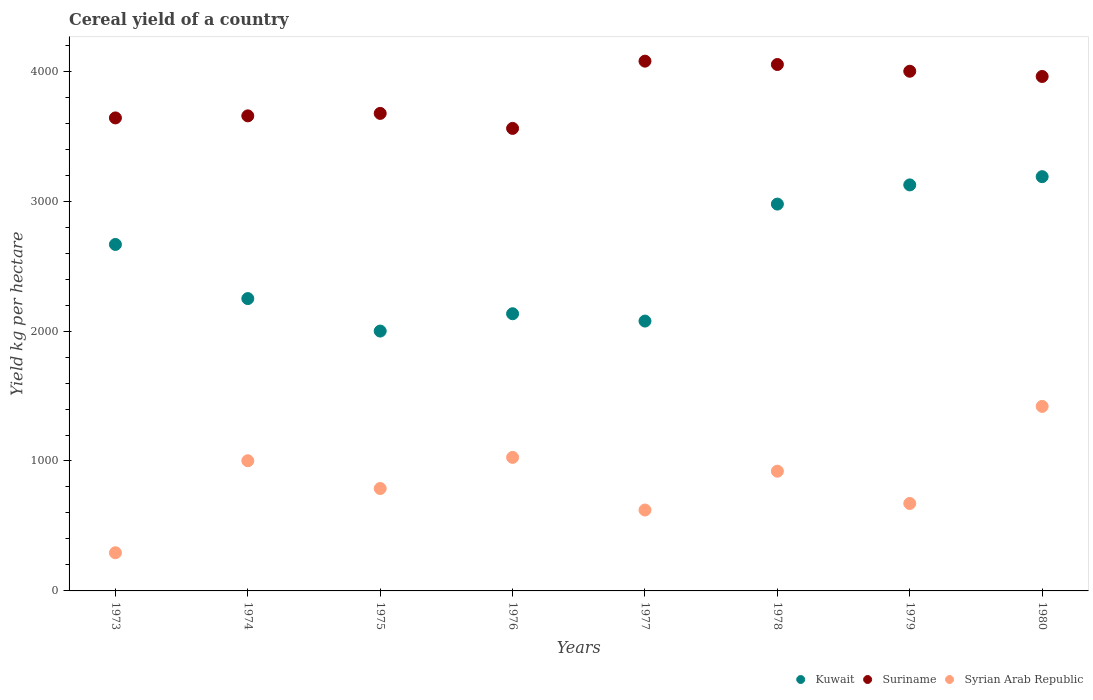How many different coloured dotlines are there?
Your answer should be compact. 3. What is the total cereal yield in Suriname in 1980?
Make the answer very short. 3959.52. Across all years, what is the maximum total cereal yield in Syrian Arab Republic?
Offer a very short reply. 1420.35. Across all years, what is the minimum total cereal yield in Syrian Arab Republic?
Your answer should be very brief. 293.83. In which year was the total cereal yield in Kuwait minimum?
Offer a very short reply. 1975. What is the total total cereal yield in Suriname in the graph?
Your answer should be very brief. 3.06e+04. What is the difference between the total cereal yield in Kuwait in 1978 and that in 1979?
Provide a succinct answer. -147.73. What is the difference between the total cereal yield in Syrian Arab Republic in 1980 and the total cereal yield in Suriname in 1974?
Offer a terse response. -2236.03. What is the average total cereal yield in Suriname per year?
Offer a very short reply. 3827.56. In the year 1978, what is the difference between the total cereal yield in Syrian Arab Republic and total cereal yield in Suriname?
Offer a very short reply. -3130.17. What is the ratio of the total cereal yield in Suriname in 1977 to that in 1980?
Offer a very short reply. 1.03. Is the total cereal yield in Kuwait in 1973 less than that in 1974?
Your response must be concise. No. Is the difference between the total cereal yield in Syrian Arab Republic in 1973 and 1980 greater than the difference between the total cereal yield in Suriname in 1973 and 1980?
Offer a terse response. No. What is the difference between the highest and the second highest total cereal yield in Kuwait?
Offer a terse response. 63.41. What is the difference between the highest and the lowest total cereal yield in Syrian Arab Republic?
Provide a short and direct response. 1126.52. Is the sum of the total cereal yield in Syrian Arab Republic in 1973 and 1980 greater than the maximum total cereal yield in Suriname across all years?
Your answer should be very brief. No. Is it the case that in every year, the sum of the total cereal yield in Suriname and total cereal yield in Kuwait  is greater than the total cereal yield in Syrian Arab Republic?
Make the answer very short. Yes. Does the total cereal yield in Syrian Arab Republic monotonically increase over the years?
Offer a terse response. No. Is the total cereal yield in Kuwait strictly greater than the total cereal yield in Syrian Arab Republic over the years?
Your answer should be compact. Yes. Is the total cereal yield in Kuwait strictly less than the total cereal yield in Suriname over the years?
Provide a succinct answer. Yes. How many years are there in the graph?
Keep it short and to the point. 8. What is the difference between two consecutive major ticks on the Y-axis?
Ensure brevity in your answer.  1000. Does the graph contain any zero values?
Provide a short and direct response. No. Does the graph contain grids?
Ensure brevity in your answer.  No. Where does the legend appear in the graph?
Your response must be concise. Bottom right. How many legend labels are there?
Provide a succinct answer. 3. How are the legend labels stacked?
Offer a terse response. Horizontal. What is the title of the graph?
Your answer should be compact. Cereal yield of a country. What is the label or title of the X-axis?
Offer a terse response. Years. What is the label or title of the Y-axis?
Give a very brief answer. Yield kg per hectare. What is the Yield kg per hectare of Kuwait in 1973?
Your response must be concise. 2666.67. What is the Yield kg per hectare in Suriname in 1973?
Your response must be concise. 3640.58. What is the Yield kg per hectare of Syrian Arab Republic in 1973?
Give a very brief answer. 293.83. What is the Yield kg per hectare of Kuwait in 1974?
Your response must be concise. 2250. What is the Yield kg per hectare in Suriname in 1974?
Your answer should be very brief. 3656.38. What is the Yield kg per hectare in Syrian Arab Republic in 1974?
Offer a very short reply. 1001.9. What is the Yield kg per hectare in Kuwait in 1975?
Provide a succinct answer. 2000. What is the Yield kg per hectare of Suriname in 1975?
Your answer should be compact. 3675.34. What is the Yield kg per hectare in Syrian Arab Republic in 1975?
Provide a short and direct response. 788.24. What is the Yield kg per hectare of Kuwait in 1976?
Keep it short and to the point. 2133.33. What is the Yield kg per hectare in Suriname in 1976?
Offer a very short reply. 3559.86. What is the Yield kg per hectare in Syrian Arab Republic in 1976?
Give a very brief answer. 1027.72. What is the Yield kg per hectare of Kuwait in 1977?
Provide a succinct answer. 2076.92. What is the Yield kg per hectare of Suriname in 1977?
Your answer should be compact. 4077.41. What is the Yield kg per hectare of Syrian Arab Republic in 1977?
Provide a short and direct response. 622.7. What is the Yield kg per hectare of Kuwait in 1978?
Offer a very short reply. 2977.27. What is the Yield kg per hectare in Suriname in 1978?
Your response must be concise. 4051.66. What is the Yield kg per hectare in Syrian Arab Republic in 1978?
Your answer should be very brief. 921.49. What is the Yield kg per hectare of Kuwait in 1979?
Offer a terse response. 3125. What is the Yield kg per hectare of Suriname in 1979?
Offer a terse response. 3999.73. What is the Yield kg per hectare in Syrian Arab Republic in 1979?
Your response must be concise. 673.16. What is the Yield kg per hectare of Kuwait in 1980?
Your answer should be very brief. 3188.41. What is the Yield kg per hectare of Suriname in 1980?
Keep it short and to the point. 3959.52. What is the Yield kg per hectare in Syrian Arab Republic in 1980?
Provide a short and direct response. 1420.35. Across all years, what is the maximum Yield kg per hectare in Kuwait?
Your answer should be very brief. 3188.41. Across all years, what is the maximum Yield kg per hectare of Suriname?
Make the answer very short. 4077.41. Across all years, what is the maximum Yield kg per hectare in Syrian Arab Republic?
Provide a short and direct response. 1420.35. Across all years, what is the minimum Yield kg per hectare of Kuwait?
Your response must be concise. 2000. Across all years, what is the minimum Yield kg per hectare in Suriname?
Ensure brevity in your answer.  3559.86. Across all years, what is the minimum Yield kg per hectare of Syrian Arab Republic?
Provide a short and direct response. 293.83. What is the total Yield kg per hectare in Kuwait in the graph?
Provide a short and direct response. 2.04e+04. What is the total Yield kg per hectare of Suriname in the graph?
Offer a very short reply. 3.06e+04. What is the total Yield kg per hectare in Syrian Arab Republic in the graph?
Provide a short and direct response. 6749.39. What is the difference between the Yield kg per hectare in Kuwait in 1973 and that in 1974?
Provide a short and direct response. 416.67. What is the difference between the Yield kg per hectare in Suriname in 1973 and that in 1974?
Keep it short and to the point. -15.79. What is the difference between the Yield kg per hectare of Syrian Arab Republic in 1973 and that in 1974?
Keep it short and to the point. -708.08. What is the difference between the Yield kg per hectare of Kuwait in 1973 and that in 1975?
Your response must be concise. 666.67. What is the difference between the Yield kg per hectare of Suriname in 1973 and that in 1975?
Your answer should be very brief. -34.75. What is the difference between the Yield kg per hectare of Syrian Arab Republic in 1973 and that in 1975?
Provide a succinct answer. -494.42. What is the difference between the Yield kg per hectare in Kuwait in 1973 and that in 1976?
Give a very brief answer. 533.33. What is the difference between the Yield kg per hectare of Suriname in 1973 and that in 1976?
Give a very brief answer. 80.72. What is the difference between the Yield kg per hectare in Syrian Arab Republic in 1973 and that in 1976?
Your answer should be very brief. -733.89. What is the difference between the Yield kg per hectare in Kuwait in 1973 and that in 1977?
Provide a short and direct response. 589.74. What is the difference between the Yield kg per hectare of Suriname in 1973 and that in 1977?
Make the answer very short. -436.83. What is the difference between the Yield kg per hectare of Syrian Arab Republic in 1973 and that in 1977?
Ensure brevity in your answer.  -328.87. What is the difference between the Yield kg per hectare of Kuwait in 1973 and that in 1978?
Keep it short and to the point. -310.61. What is the difference between the Yield kg per hectare of Suriname in 1973 and that in 1978?
Keep it short and to the point. -411.08. What is the difference between the Yield kg per hectare in Syrian Arab Republic in 1973 and that in 1978?
Make the answer very short. -627.66. What is the difference between the Yield kg per hectare of Kuwait in 1973 and that in 1979?
Your response must be concise. -458.33. What is the difference between the Yield kg per hectare of Suriname in 1973 and that in 1979?
Offer a very short reply. -359.15. What is the difference between the Yield kg per hectare of Syrian Arab Republic in 1973 and that in 1979?
Provide a succinct answer. -379.33. What is the difference between the Yield kg per hectare in Kuwait in 1973 and that in 1980?
Offer a terse response. -521.74. What is the difference between the Yield kg per hectare of Suriname in 1973 and that in 1980?
Your answer should be compact. -318.94. What is the difference between the Yield kg per hectare of Syrian Arab Republic in 1973 and that in 1980?
Keep it short and to the point. -1126.52. What is the difference between the Yield kg per hectare of Kuwait in 1974 and that in 1975?
Keep it short and to the point. 250. What is the difference between the Yield kg per hectare of Suriname in 1974 and that in 1975?
Keep it short and to the point. -18.96. What is the difference between the Yield kg per hectare of Syrian Arab Republic in 1974 and that in 1975?
Offer a terse response. 213.66. What is the difference between the Yield kg per hectare of Kuwait in 1974 and that in 1976?
Give a very brief answer. 116.67. What is the difference between the Yield kg per hectare in Suriname in 1974 and that in 1976?
Give a very brief answer. 96.51. What is the difference between the Yield kg per hectare in Syrian Arab Republic in 1974 and that in 1976?
Give a very brief answer. -25.82. What is the difference between the Yield kg per hectare of Kuwait in 1974 and that in 1977?
Ensure brevity in your answer.  173.08. What is the difference between the Yield kg per hectare in Suriname in 1974 and that in 1977?
Provide a short and direct response. -421.04. What is the difference between the Yield kg per hectare of Syrian Arab Republic in 1974 and that in 1977?
Offer a very short reply. 379.2. What is the difference between the Yield kg per hectare of Kuwait in 1974 and that in 1978?
Your answer should be very brief. -727.27. What is the difference between the Yield kg per hectare in Suriname in 1974 and that in 1978?
Provide a short and direct response. -395.29. What is the difference between the Yield kg per hectare of Syrian Arab Republic in 1974 and that in 1978?
Offer a terse response. 80.42. What is the difference between the Yield kg per hectare in Kuwait in 1974 and that in 1979?
Your answer should be very brief. -875. What is the difference between the Yield kg per hectare of Suriname in 1974 and that in 1979?
Your answer should be very brief. -343.35. What is the difference between the Yield kg per hectare of Syrian Arab Republic in 1974 and that in 1979?
Keep it short and to the point. 328.75. What is the difference between the Yield kg per hectare in Kuwait in 1974 and that in 1980?
Offer a very short reply. -938.41. What is the difference between the Yield kg per hectare in Suriname in 1974 and that in 1980?
Your answer should be compact. -303.14. What is the difference between the Yield kg per hectare in Syrian Arab Republic in 1974 and that in 1980?
Offer a terse response. -418.45. What is the difference between the Yield kg per hectare in Kuwait in 1975 and that in 1976?
Keep it short and to the point. -133.33. What is the difference between the Yield kg per hectare in Suriname in 1975 and that in 1976?
Your answer should be very brief. 115.47. What is the difference between the Yield kg per hectare in Syrian Arab Republic in 1975 and that in 1976?
Keep it short and to the point. -239.48. What is the difference between the Yield kg per hectare of Kuwait in 1975 and that in 1977?
Give a very brief answer. -76.92. What is the difference between the Yield kg per hectare of Suriname in 1975 and that in 1977?
Your answer should be very brief. -402.08. What is the difference between the Yield kg per hectare of Syrian Arab Republic in 1975 and that in 1977?
Your answer should be very brief. 165.54. What is the difference between the Yield kg per hectare in Kuwait in 1975 and that in 1978?
Ensure brevity in your answer.  -977.27. What is the difference between the Yield kg per hectare of Suriname in 1975 and that in 1978?
Give a very brief answer. -376.33. What is the difference between the Yield kg per hectare in Syrian Arab Republic in 1975 and that in 1978?
Offer a very short reply. -133.25. What is the difference between the Yield kg per hectare of Kuwait in 1975 and that in 1979?
Give a very brief answer. -1125. What is the difference between the Yield kg per hectare in Suriname in 1975 and that in 1979?
Keep it short and to the point. -324.39. What is the difference between the Yield kg per hectare of Syrian Arab Republic in 1975 and that in 1979?
Keep it short and to the point. 115.09. What is the difference between the Yield kg per hectare of Kuwait in 1975 and that in 1980?
Offer a terse response. -1188.41. What is the difference between the Yield kg per hectare of Suriname in 1975 and that in 1980?
Keep it short and to the point. -284.18. What is the difference between the Yield kg per hectare of Syrian Arab Republic in 1975 and that in 1980?
Offer a terse response. -632.11. What is the difference between the Yield kg per hectare of Kuwait in 1976 and that in 1977?
Your answer should be compact. 56.41. What is the difference between the Yield kg per hectare in Suriname in 1976 and that in 1977?
Your answer should be compact. -517.55. What is the difference between the Yield kg per hectare of Syrian Arab Republic in 1976 and that in 1977?
Offer a very short reply. 405.02. What is the difference between the Yield kg per hectare in Kuwait in 1976 and that in 1978?
Offer a very short reply. -843.94. What is the difference between the Yield kg per hectare of Suriname in 1976 and that in 1978?
Your response must be concise. -491.8. What is the difference between the Yield kg per hectare in Syrian Arab Republic in 1976 and that in 1978?
Offer a very short reply. 106.23. What is the difference between the Yield kg per hectare in Kuwait in 1976 and that in 1979?
Make the answer very short. -991.67. What is the difference between the Yield kg per hectare of Suriname in 1976 and that in 1979?
Your answer should be very brief. -439.87. What is the difference between the Yield kg per hectare of Syrian Arab Republic in 1976 and that in 1979?
Offer a very short reply. 354.56. What is the difference between the Yield kg per hectare of Kuwait in 1976 and that in 1980?
Give a very brief answer. -1055.07. What is the difference between the Yield kg per hectare in Suriname in 1976 and that in 1980?
Your response must be concise. -399.65. What is the difference between the Yield kg per hectare in Syrian Arab Republic in 1976 and that in 1980?
Provide a short and direct response. -392.63. What is the difference between the Yield kg per hectare in Kuwait in 1977 and that in 1978?
Offer a terse response. -900.35. What is the difference between the Yield kg per hectare in Suriname in 1977 and that in 1978?
Provide a short and direct response. 25.75. What is the difference between the Yield kg per hectare in Syrian Arab Republic in 1977 and that in 1978?
Your answer should be compact. -298.79. What is the difference between the Yield kg per hectare of Kuwait in 1977 and that in 1979?
Your answer should be very brief. -1048.08. What is the difference between the Yield kg per hectare in Suriname in 1977 and that in 1979?
Offer a very short reply. 77.69. What is the difference between the Yield kg per hectare in Syrian Arab Republic in 1977 and that in 1979?
Provide a succinct answer. -50.46. What is the difference between the Yield kg per hectare of Kuwait in 1977 and that in 1980?
Your response must be concise. -1111.48. What is the difference between the Yield kg per hectare in Suriname in 1977 and that in 1980?
Make the answer very short. 117.9. What is the difference between the Yield kg per hectare of Syrian Arab Republic in 1977 and that in 1980?
Provide a short and direct response. -797.65. What is the difference between the Yield kg per hectare of Kuwait in 1978 and that in 1979?
Ensure brevity in your answer.  -147.73. What is the difference between the Yield kg per hectare of Suriname in 1978 and that in 1979?
Provide a short and direct response. 51.93. What is the difference between the Yield kg per hectare of Syrian Arab Republic in 1978 and that in 1979?
Provide a short and direct response. 248.33. What is the difference between the Yield kg per hectare of Kuwait in 1978 and that in 1980?
Your response must be concise. -211.13. What is the difference between the Yield kg per hectare in Suriname in 1978 and that in 1980?
Give a very brief answer. 92.14. What is the difference between the Yield kg per hectare of Syrian Arab Republic in 1978 and that in 1980?
Your answer should be compact. -498.86. What is the difference between the Yield kg per hectare in Kuwait in 1979 and that in 1980?
Your answer should be very brief. -63.41. What is the difference between the Yield kg per hectare in Suriname in 1979 and that in 1980?
Provide a short and direct response. 40.21. What is the difference between the Yield kg per hectare in Syrian Arab Republic in 1979 and that in 1980?
Your response must be concise. -747.19. What is the difference between the Yield kg per hectare of Kuwait in 1973 and the Yield kg per hectare of Suriname in 1974?
Your answer should be very brief. -989.71. What is the difference between the Yield kg per hectare in Kuwait in 1973 and the Yield kg per hectare in Syrian Arab Republic in 1974?
Make the answer very short. 1664.76. What is the difference between the Yield kg per hectare of Suriname in 1973 and the Yield kg per hectare of Syrian Arab Republic in 1974?
Give a very brief answer. 2638.68. What is the difference between the Yield kg per hectare of Kuwait in 1973 and the Yield kg per hectare of Suriname in 1975?
Give a very brief answer. -1008.67. What is the difference between the Yield kg per hectare in Kuwait in 1973 and the Yield kg per hectare in Syrian Arab Republic in 1975?
Offer a terse response. 1878.42. What is the difference between the Yield kg per hectare of Suriname in 1973 and the Yield kg per hectare of Syrian Arab Republic in 1975?
Offer a very short reply. 2852.34. What is the difference between the Yield kg per hectare in Kuwait in 1973 and the Yield kg per hectare in Suriname in 1976?
Your response must be concise. -893.2. What is the difference between the Yield kg per hectare of Kuwait in 1973 and the Yield kg per hectare of Syrian Arab Republic in 1976?
Offer a terse response. 1638.95. What is the difference between the Yield kg per hectare of Suriname in 1973 and the Yield kg per hectare of Syrian Arab Republic in 1976?
Give a very brief answer. 2612.86. What is the difference between the Yield kg per hectare of Kuwait in 1973 and the Yield kg per hectare of Suriname in 1977?
Provide a succinct answer. -1410.75. What is the difference between the Yield kg per hectare in Kuwait in 1973 and the Yield kg per hectare in Syrian Arab Republic in 1977?
Your response must be concise. 2043.97. What is the difference between the Yield kg per hectare of Suriname in 1973 and the Yield kg per hectare of Syrian Arab Republic in 1977?
Your response must be concise. 3017.88. What is the difference between the Yield kg per hectare in Kuwait in 1973 and the Yield kg per hectare in Suriname in 1978?
Offer a terse response. -1384.99. What is the difference between the Yield kg per hectare in Kuwait in 1973 and the Yield kg per hectare in Syrian Arab Republic in 1978?
Offer a very short reply. 1745.18. What is the difference between the Yield kg per hectare in Suriname in 1973 and the Yield kg per hectare in Syrian Arab Republic in 1978?
Ensure brevity in your answer.  2719.09. What is the difference between the Yield kg per hectare of Kuwait in 1973 and the Yield kg per hectare of Suriname in 1979?
Your response must be concise. -1333.06. What is the difference between the Yield kg per hectare of Kuwait in 1973 and the Yield kg per hectare of Syrian Arab Republic in 1979?
Your answer should be very brief. 1993.51. What is the difference between the Yield kg per hectare in Suriname in 1973 and the Yield kg per hectare in Syrian Arab Republic in 1979?
Keep it short and to the point. 2967.42. What is the difference between the Yield kg per hectare of Kuwait in 1973 and the Yield kg per hectare of Suriname in 1980?
Give a very brief answer. -1292.85. What is the difference between the Yield kg per hectare in Kuwait in 1973 and the Yield kg per hectare in Syrian Arab Republic in 1980?
Offer a very short reply. 1246.32. What is the difference between the Yield kg per hectare in Suriname in 1973 and the Yield kg per hectare in Syrian Arab Republic in 1980?
Keep it short and to the point. 2220.23. What is the difference between the Yield kg per hectare in Kuwait in 1974 and the Yield kg per hectare in Suriname in 1975?
Your response must be concise. -1425.34. What is the difference between the Yield kg per hectare in Kuwait in 1974 and the Yield kg per hectare in Syrian Arab Republic in 1975?
Provide a succinct answer. 1461.76. What is the difference between the Yield kg per hectare of Suriname in 1974 and the Yield kg per hectare of Syrian Arab Republic in 1975?
Make the answer very short. 2868.13. What is the difference between the Yield kg per hectare in Kuwait in 1974 and the Yield kg per hectare in Suriname in 1976?
Make the answer very short. -1309.86. What is the difference between the Yield kg per hectare in Kuwait in 1974 and the Yield kg per hectare in Syrian Arab Republic in 1976?
Provide a short and direct response. 1222.28. What is the difference between the Yield kg per hectare of Suriname in 1974 and the Yield kg per hectare of Syrian Arab Republic in 1976?
Your answer should be compact. 2628.66. What is the difference between the Yield kg per hectare of Kuwait in 1974 and the Yield kg per hectare of Suriname in 1977?
Make the answer very short. -1827.41. What is the difference between the Yield kg per hectare in Kuwait in 1974 and the Yield kg per hectare in Syrian Arab Republic in 1977?
Ensure brevity in your answer.  1627.3. What is the difference between the Yield kg per hectare in Suriname in 1974 and the Yield kg per hectare in Syrian Arab Republic in 1977?
Offer a terse response. 3033.68. What is the difference between the Yield kg per hectare of Kuwait in 1974 and the Yield kg per hectare of Suriname in 1978?
Keep it short and to the point. -1801.66. What is the difference between the Yield kg per hectare in Kuwait in 1974 and the Yield kg per hectare in Syrian Arab Republic in 1978?
Give a very brief answer. 1328.51. What is the difference between the Yield kg per hectare of Suriname in 1974 and the Yield kg per hectare of Syrian Arab Republic in 1978?
Offer a terse response. 2734.89. What is the difference between the Yield kg per hectare of Kuwait in 1974 and the Yield kg per hectare of Suriname in 1979?
Give a very brief answer. -1749.73. What is the difference between the Yield kg per hectare of Kuwait in 1974 and the Yield kg per hectare of Syrian Arab Republic in 1979?
Your answer should be very brief. 1576.84. What is the difference between the Yield kg per hectare in Suriname in 1974 and the Yield kg per hectare in Syrian Arab Republic in 1979?
Your answer should be very brief. 2983.22. What is the difference between the Yield kg per hectare of Kuwait in 1974 and the Yield kg per hectare of Suriname in 1980?
Ensure brevity in your answer.  -1709.52. What is the difference between the Yield kg per hectare in Kuwait in 1974 and the Yield kg per hectare in Syrian Arab Republic in 1980?
Provide a short and direct response. 829.65. What is the difference between the Yield kg per hectare of Suriname in 1974 and the Yield kg per hectare of Syrian Arab Republic in 1980?
Provide a short and direct response. 2236.03. What is the difference between the Yield kg per hectare of Kuwait in 1975 and the Yield kg per hectare of Suriname in 1976?
Offer a very short reply. -1559.86. What is the difference between the Yield kg per hectare in Kuwait in 1975 and the Yield kg per hectare in Syrian Arab Republic in 1976?
Ensure brevity in your answer.  972.28. What is the difference between the Yield kg per hectare in Suriname in 1975 and the Yield kg per hectare in Syrian Arab Republic in 1976?
Provide a succinct answer. 2647.61. What is the difference between the Yield kg per hectare in Kuwait in 1975 and the Yield kg per hectare in Suriname in 1977?
Your answer should be compact. -2077.41. What is the difference between the Yield kg per hectare in Kuwait in 1975 and the Yield kg per hectare in Syrian Arab Republic in 1977?
Provide a short and direct response. 1377.3. What is the difference between the Yield kg per hectare in Suriname in 1975 and the Yield kg per hectare in Syrian Arab Republic in 1977?
Offer a very short reply. 3052.63. What is the difference between the Yield kg per hectare in Kuwait in 1975 and the Yield kg per hectare in Suriname in 1978?
Your answer should be very brief. -2051.66. What is the difference between the Yield kg per hectare in Kuwait in 1975 and the Yield kg per hectare in Syrian Arab Republic in 1978?
Make the answer very short. 1078.51. What is the difference between the Yield kg per hectare of Suriname in 1975 and the Yield kg per hectare of Syrian Arab Republic in 1978?
Make the answer very short. 2753.85. What is the difference between the Yield kg per hectare in Kuwait in 1975 and the Yield kg per hectare in Suriname in 1979?
Your response must be concise. -1999.73. What is the difference between the Yield kg per hectare in Kuwait in 1975 and the Yield kg per hectare in Syrian Arab Republic in 1979?
Your answer should be very brief. 1326.84. What is the difference between the Yield kg per hectare of Suriname in 1975 and the Yield kg per hectare of Syrian Arab Republic in 1979?
Make the answer very short. 3002.18. What is the difference between the Yield kg per hectare in Kuwait in 1975 and the Yield kg per hectare in Suriname in 1980?
Your answer should be compact. -1959.52. What is the difference between the Yield kg per hectare of Kuwait in 1975 and the Yield kg per hectare of Syrian Arab Republic in 1980?
Provide a short and direct response. 579.65. What is the difference between the Yield kg per hectare of Suriname in 1975 and the Yield kg per hectare of Syrian Arab Republic in 1980?
Provide a succinct answer. 2254.98. What is the difference between the Yield kg per hectare of Kuwait in 1976 and the Yield kg per hectare of Suriname in 1977?
Provide a short and direct response. -1944.08. What is the difference between the Yield kg per hectare of Kuwait in 1976 and the Yield kg per hectare of Syrian Arab Republic in 1977?
Keep it short and to the point. 1510.63. What is the difference between the Yield kg per hectare in Suriname in 1976 and the Yield kg per hectare in Syrian Arab Republic in 1977?
Your response must be concise. 2937.16. What is the difference between the Yield kg per hectare in Kuwait in 1976 and the Yield kg per hectare in Suriname in 1978?
Provide a succinct answer. -1918.33. What is the difference between the Yield kg per hectare of Kuwait in 1976 and the Yield kg per hectare of Syrian Arab Republic in 1978?
Provide a short and direct response. 1211.84. What is the difference between the Yield kg per hectare in Suriname in 1976 and the Yield kg per hectare in Syrian Arab Republic in 1978?
Provide a short and direct response. 2638.37. What is the difference between the Yield kg per hectare of Kuwait in 1976 and the Yield kg per hectare of Suriname in 1979?
Offer a very short reply. -1866.4. What is the difference between the Yield kg per hectare of Kuwait in 1976 and the Yield kg per hectare of Syrian Arab Republic in 1979?
Ensure brevity in your answer.  1460.18. What is the difference between the Yield kg per hectare in Suriname in 1976 and the Yield kg per hectare in Syrian Arab Republic in 1979?
Your answer should be very brief. 2886.71. What is the difference between the Yield kg per hectare of Kuwait in 1976 and the Yield kg per hectare of Suriname in 1980?
Give a very brief answer. -1826.18. What is the difference between the Yield kg per hectare in Kuwait in 1976 and the Yield kg per hectare in Syrian Arab Republic in 1980?
Ensure brevity in your answer.  712.98. What is the difference between the Yield kg per hectare of Suriname in 1976 and the Yield kg per hectare of Syrian Arab Republic in 1980?
Your response must be concise. 2139.51. What is the difference between the Yield kg per hectare in Kuwait in 1977 and the Yield kg per hectare in Suriname in 1978?
Keep it short and to the point. -1974.74. What is the difference between the Yield kg per hectare of Kuwait in 1977 and the Yield kg per hectare of Syrian Arab Republic in 1978?
Your response must be concise. 1155.43. What is the difference between the Yield kg per hectare in Suriname in 1977 and the Yield kg per hectare in Syrian Arab Republic in 1978?
Provide a short and direct response. 3155.93. What is the difference between the Yield kg per hectare of Kuwait in 1977 and the Yield kg per hectare of Suriname in 1979?
Your response must be concise. -1922.81. What is the difference between the Yield kg per hectare in Kuwait in 1977 and the Yield kg per hectare in Syrian Arab Republic in 1979?
Give a very brief answer. 1403.77. What is the difference between the Yield kg per hectare of Suriname in 1977 and the Yield kg per hectare of Syrian Arab Republic in 1979?
Your answer should be compact. 3404.26. What is the difference between the Yield kg per hectare of Kuwait in 1977 and the Yield kg per hectare of Suriname in 1980?
Your answer should be very brief. -1882.59. What is the difference between the Yield kg per hectare of Kuwait in 1977 and the Yield kg per hectare of Syrian Arab Republic in 1980?
Provide a short and direct response. 656.57. What is the difference between the Yield kg per hectare in Suriname in 1977 and the Yield kg per hectare in Syrian Arab Republic in 1980?
Your answer should be very brief. 2657.06. What is the difference between the Yield kg per hectare in Kuwait in 1978 and the Yield kg per hectare in Suriname in 1979?
Provide a short and direct response. -1022.46. What is the difference between the Yield kg per hectare of Kuwait in 1978 and the Yield kg per hectare of Syrian Arab Republic in 1979?
Provide a short and direct response. 2304.12. What is the difference between the Yield kg per hectare in Suriname in 1978 and the Yield kg per hectare in Syrian Arab Republic in 1979?
Provide a short and direct response. 3378.51. What is the difference between the Yield kg per hectare in Kuwait in 1978 and the Yield kg per hectare in Suriname in 1980?
Your answer should be compact. -982.24. What is the difference between the Yield kg per hectare of Kuwait in 1978 and the Yield kg per hectare of Syrian Arab Republic in 1980?
Provide a short and direct response. 1556.92. What is the difference between the Yield kg per hectare of Suriname in 1978 and the Yield kg per hectare of Syrian Arab Republic in 1980?
Make the answer very short. 2631.31. What is the difference between the Yield kg per hectare in Kuwait in 1979 and the Yield kg per hectare in Suriname in 1980?
Make the answer very short. -834.52. What is the difference between the Yield kg per hectare in Kuwait in 1979 and the Yield kg per hectare in Syrian Arab Republic in 1980?
Offer a very short reply. 1704.65. What is the difference between the Yield kg per hectare of Suriname in 1979 and the Yield kg per hectare of Syrian Arab Republic in 1980?
Make the answer very short. 2579.38. What is the average Yield kg per hectare in Kuwait per year?
Your answer should be very brief. 2552.2. What is the average Yield kg per hectare of Suriname per year?
Give a very brief answer. 3827.56. What is the average Yield kg per hectare in Syrian Arab Republic per year?
Make the answer very short. 843.67. In the year 1973, what is the difference between the Yield kg per hectare of Kuwait and Yield kg per hectare of Suriname?
Provide a short and direct response. -973.91. In the year 1973, what is the difference between the Yield kg per hectare in Kuwait and Yield kg per hectare in Syrian Arab Republic?
Keep it short and to the point. 2372.84. In the year 1973, what is the difference between the Yield kg per hectare of Suriname and Yield kg per hectare of Syrian Arab Republic?
Keep it short and to the point. 3346.75. In the year 1974, what is the difference between the Yield kg per hectare of Kuwait and Yield kg per hectare of Suriname?
Your answer should be very brief. -1406.38. In the year 1974, what is the difference between the Yield kg per hectare in Kuwait and Yield kg per hectare in Syrian Arab Republic?
Provide a short and direct response. 1248.1. In the year 1974, what is the difference between the Yield kg per hectare of Suriname and Yield kg per hectare of Syrian Arab Republic?
Your answer should be compact. 2654.47. In the year 1975, what is the difference between the Yield kg per hectare of Kuwait and Yield kg per hectare of Suriname?
Your answer should be compact. -1675.34. In the year 1975, what is the difference between the Yield kg per hectare in Kuwait and Yield kg per hectare in Syrian Arab Republic?
Keep it short and to the point. 1211.76. In the year 1975, what is the difference between the Yield kg per hectare in Suriname and Yield kg per hectare in Syrian Arab Republic?
Offer a very short reply. 2887.09. In the year 1976, what is the difference between the Yield kg per hectare of Kuwait and Yield kg per hectare of Suriname?
Make the answer very short. -1426.53. In the year 1976, what is the difference between the Yield kg per hectare of Kuwait and Yield kg per hectare of Syrian Arab Republic?
Offer a terse response. 1105.61. In the year 1976, what is the difference between the Yield kg per hectare in Suriname and Yield kg per hectare in Syrian Arab Republic?
Keep it short and to the point. 2532.14. In the year 1977, what is the difference between the Yield kg per hectare of Kuwait and Yield kg per hectare of Suriname?
Keep it short and to the point. -2000.49. In the year 1977, what is the difference between the Yield kg per hectare in Kuwait and Yield kg per hectare in Syrian Arab Republic?
Offer a terse response. 1454.22. In the year 1977, what is the difference between the Yield kg per hectare of Suriname and Yield kg per hectare of Syrian Arab Republic?
Provide a succinct answer. 3454.71. In the year 1978, what is the difference between the Yield kg per hectare of Kuwait and Yield kg per hectare of Suriname?
Make the answer very short. -1074.39. In the year 1978, what is the difference between the Yield kg per hectare in Kuwait and Yield kg per hectare in Syrian Arab Republic?
Your answer should be compact. 2055.78. In the year 1978, what is the difference between the Yield kg per hectare of Suriname and Yield kg per hectare of Syrian Arab Republic?
Your response must be concise. 3130.17. In the year 1979, what is the difference between the Yield kg per hectare of Kuwait and Yield kg per hectare of Suriname?
Your answer should be compact. -874.73. In the year 1979, what is the difference between the Yield kg per hectare in Kuwait and Yield kg per hectare in Syrian Arab Republic?
Your answer should be very brief. 2451.84. In the year 1979, what is the difference between the Yield kg per hectare in Suriname and Yield kg per hectare in Syrian Arab Republic?
Make the answer very short. 3326.57. In the year 1980, what is the difference between the Yield kg per hectare in Kuwait and Yield kg per hectare in Suriname?
Offer a very short reply. -771.11. In the year 1980, what is the difference between the Yield kg per hectare in Kuwait and Yield kg per hectare in Syrian Arab Republic?
Ensure brevity in your answer.  1768.06. In the year 1980, what is the difference between the Yield kg per hectare in Suriname and Yield kg per hectare in Syrian Arab Republic?
Your response must be concise. 2539.17. What is the ratio of the Yield kg per hectare of Kuwait in 1973 to that in 1974?
Provide a succinct answer. 1.19. What is the ratio of the Yield kg per hectare of Suriname in 1973 to that in 1974?
Your answer should be very brief. 1. What is the ratio of the Yield kg per hectare in Syrian Arab Republic in 1973 to that in 1974?
Ensure brevity in your answer.  0.29. What is the ratio of the Yield kg per hectare in Syrian Arab Republic in 1973 to that in 1975?
Give a very brief answer. 0.37. What is the ratio of the Yield kg per hectare of Kuwait in 1973 to that in 1976?
Provide a succinct answer. 1.25. What is the ratio of the Yield kg per hectare in Suriname in 1973 to that in 1976?
Offer a terse response. 1.02. What is the ratio of the Yield kg per hectare of Syrian Arab Republic in 1973 to that in 1976?
Ensure brevity in your answer.  0.29. What is the ratio of the Yield kg per hectare in Kuwait in 1973 to that in 1977?
Your response must be concise. 1.28. What is the ratio of the Yield kg per hectare of Suriname in 1973 to that in 1977?
Offer a terse response. 0.89. What is the ratio of the Yield kg per hectare in Syrian Arab Republic in 1973 to that in 1977?
Your response must be concise. 0.47. What is the ratio of the Yield kg per hectare in Kuwait in 1973 to that in 1978?
Give a very brief answer. 0.9. What is the ratio of the Yield kg per hectare of Suriname in 1973 to that in 1978?
Your response must be concise. 0.9. What is the ratio of the Yield kg per hectare of Syrian Arab Republic in 1973 to that in 1978?
Provide a succinct answer. 0.32. What is the ratio of the Yield kg per hectare in Kuwait in 1973 to that in 1979?
Provide a succinct answer. 0.85. What is the ratio of the Yield kg per hectare in Suriname in 1973 to that in 1979?
Make the answer very short. 0.91. What is the ratio of the Yield kg per hectare in Syrian Arab Republic in 1973 to that in 1979?
Ensure brevity in your answer.  0.44. What is the ratio of the Yield kg per hectare of Kuwait in 1973 to that in 1980?
Give a very brief answer. 0.84. What is the ratio of the Yield kg per hectare of Suriname in 1973 to that in 1980?
Your response must be concise. 0.92. What is the ratio of the Yield kg per hectare in Syrian Arab Republic in 1973 to that in 1980?
Keep it short and to the point. 0.21. What is the ratio of the Yield kg per hectare of Kuwait in 1974 to that in 1975?
Your answer should be compact. 1.12. What is the ratio of the Yield kg per hectare in Syrian Arab Republic in 1974 to that in 1975?
Offer a very short reply. 1.27. What is the ratio of the Yield kg per hectare of Kuwait in 1974 to that in 1976?
Your answer should be very brief. 1.05. What is the ratio of the Yield kg per hectare in Suriname in 1974 to that in 1976?
Provide a succinct answer. 1.03. What is the ratio of the Yield kg per hectare of Syrian Arab Republic in 1974 to that in 1976?
Make the answer very short. 0.97. What is the ratio of the Yield kg per hectare in Suriname in 1974 to that in 1977?
Your response must be concise. 0.9. What is the ratio of the Yield kg per hectare in Syrian Arab Republic in 1974 to that in 1977?
Your response must be concise. 1.61. What is the ratio of the Yield kg per hectare in Kuwait in 1974 to that in 1978?
Offer a very short reply. 0.76. What is the ratio of the Yield kg per hectare of Suriname in 1974 to that in 1978?
Make the answer very short. 0.9. What is the ratio of the Yield kg per hectare in Syrian Arab Republic in 1974 to that in 1978?
Make the answer very short. 1.09. What is the ratio of the Yield kg per hectare in Kuwait in 1974 to that in 1979?
Ensure brevity in your answer.  0.72. What is the ratio of the Yield kg per hectare of Suriname in 1974 to that in 1979?
Your answer should be very brief. 0.91. What is the ratio of the Yield kg per hectare in Syrian Arab Republic in 1974 to that in 1979?
Your response must be concise. 1.49. What is the ratio of the Yield kg per hectare of Kuwait in 1974 to that in 1980?
Keep it short and to the point. 0.71. What is the ratio of the Yield kg per hectare in Suriname in 1974 to that in 1980?
Keep it short and to the point. 0.92. What is the ratio of the Yield kg per hectare in Syrian Arab Republic in 1974 to that in 1980?
Your answer should be compact. 0.71. What is the ratio of the Yield kg per hectare in Kuwait in 1975 to that in 1976?
Provide a succinct answer. 0.94. What is the ratio of the Yield kg per hectare of Suriname in 1975 to that in 1976?
Offer a terse response. 1.03. What is the ratio of the Yield kg per hectare in Syrian Arab Republic in 1975 to that in 1976?
Offer a very short reply. 0.77. What is the ratio of the Yield kg per hectare of Kuwait in 1975 to that in 1977?
Give a very brief answer. 0.96. What is the ratio of the Yield kg per hectare in Suriname in 1975 to that in 1977?
Keep it short and to the point. 0.9. What is the ratio of the Yield kg per hectare in Syrian Arab Republic in 1975 to that in 1977?
Give a very brief answer. 1.27. What is the ratio of the Yield kg per hectare in Kuwait in 1975 to that in 1978?
Offer a terse response. 0.67. What is the ratio of the Yield kg per hectare in Suriname in 1975 to that in 1978?
Make the answer very short. 0.91. What is the ratio of the Yield kg per hectare in Syrian Arab Republic in 1975 to that in 1978?
Make the answer very short. 0.86. What is the ratio of the Yield kg per hectare of Kuwait in 1975 to that in 1979?
Offer a terse response. 0.64. What is the ratio of the Yield kg per hectare of Suriname in 1975 to that in 1979?
Ensure brevity in your answer.  0.92. What is the ratio of the Yield kg per hectare in Syrian Arab Republic in 1975 to that in 1979?
Keep it short and to the point. 1.17. What is the ratio of the Yield kg per hectare in Kuwait in 1975 to that in 1980?
Your response must be concise. 0.63. What is the ratio of the Yield kg per hectare in Suriname in 1975 to that in 1980?
Provide a short and direct response. 0.93. What is the ratio of the Yield kg per hectare of Syrian Arab Republic in 1975 to that in 1980?
Your answer should be very brief. 0.56. What is the ratio of the Yield kg per hectare in Kuwait in 1976 to that in 1977?
Make the answer very short. 1.03. What is the ratio of the Yield kg per hectare of Suriname in 1976 to that in 1977?
Offer a terse response. 0.87. What is the ratio of the Yield kg per hectare in Syrian Arab Republic in 1976 to that in 1977?
Make the answer very short. 1.65. What is the ratio of the Yield kg per hectare in Kuwait in 1976 to that in 1978?
Your answer should be very brief. 0.72. What is the ratio of the Yield kg per hectare of Suriname in 1976 to that in 1978?
Offer a very short reply. 0.88. What is the ratio of the Yield kg per hectare in Syrian Arab Republic in 1976 to that in 1978?
Give a very brief answer. 1.12. What is the ratio of the Yield kg per hectare of Kuwait in 1976 to that in 1979?
Give a very brief answer. 0.68. What is the ratio of the Yield kg per hectare of Suriname in 1976 to that in 1979?
Give a very brief answer. 0.89. What is the ratio of the Yield kg per hectare in Syrian Arab Republic in 1976 to that in 1979?
Ensure brevity in your answer.  1.53. What is the ratio of the Yield kg per hectare in Kuwait in 1976 to that in 1980?
Your answer should be compact. 0.67. What is the ratio of the Yield kg per hectare in Suriname in 1976 to that in 1980?
Your response must be concise. 0.9. What is the ratio of the Yield kg per hectare of Syrian Arab Republic in 1976 to that in 1980?
Offer a very short reply. 0.72. What is the ratio of the Yield kg per hectare of Kuwait in 1977 to that in 1978?
Offer a very short reply. 0.7. What is the ratio of the Yield kg per hectare of Suriname in 1977 to that in 1978?
Your answer should be very brief. 1.01. What is the ratio of the Yield kg per hectare in Syrian Arab Republic in 1977 to that in 1978?
Offer a terse response. 0.68. What is the ratio of the Yield kg per hectare in Kuwait in 1977 to that in 1979?
Keep it short and to the point. 0.66. What is the ratio of the Yield kg per hectare of Suriname in 1977 to that in 1979?
Provide a succinct answer. 1.02. What is the ratio of the Yield kg per hectare in Syrian Arab Republic in 1977 to that in 1979?
Keep it short and to the point. 0.93. What is the ratio of the Yield kg per hectare in Kuwait in 1977 to that in 1980?
Offer a very short reply. 0.65. What is the ratio of the Yield kg per hectare in Suriname in 1977 to that in 1980?
Give a very brief answer. 1.03. What is the ratio of the Yield kg per hectare in Syrian Arab Republic in 1977 to that in 1980?
Your response must be concise. 0.44. What is the ratio of the Yield kg per hectare of Kuwait in 1978 to that in 1979?
Ensure brevity in your answer.  0.95. What is the ratio of the Yield kg per hectare in Syrian Arab Republic in 1978 to that in 1979?
Provide a short and direct response. 1.37. What is the ratio of the Yield kg per hectare in Kuwait in 1978 to that in 1980?
Give a very brief answer. 0.93. What is the ratio of the Yield kg per hectare of Suriname in 1978 to that in 1980?
Provide a short and direct response. 1.02. What is the ratio of the Yield kg per hectare of Syrian Arab Republic in 1978 to that in 1980?
Offer a very short reply. 0.65. What is the ratio of the Yield kg per hectare of Kuwait in 1979 to that in 1980?
Give a very brief answer. 0.98. What is the ratio of the Yield kg per hectare in Suriname in 1979 to that in 1980?
Give a very brief answer. 1.01. What is the ratio of the Yield kg per hectare of Syrian Arab Republic in 1979 to that in 1980?
Your response must be concise. 0.47. What is the difference between the highest and the second highest Yield kg per hectare of Kuwait?
Keep it short and to the point. 63.41. What is the difference between the highest and the second highest Yield kg per hectare of Suriname?
Offer a terse response. 25.75. What is the difference between the highest and the second highest Yield kg per hectare in Syrian Arab Republic?
Give a very brief answer. 392.63. What is the difference between the highest and the lowest Yield kg per hectare in Kuwait?
Make the answer very short. 1188.41. What is the difference between the highest and the lowest Yield kg per hectare in Suriname?
Provide a short and direct response. 517.55. What is the difference between the highest and the lowest Yield kg per hectare in Syrian Arab Republic?
Provide a short and direct response. 1126.52. 